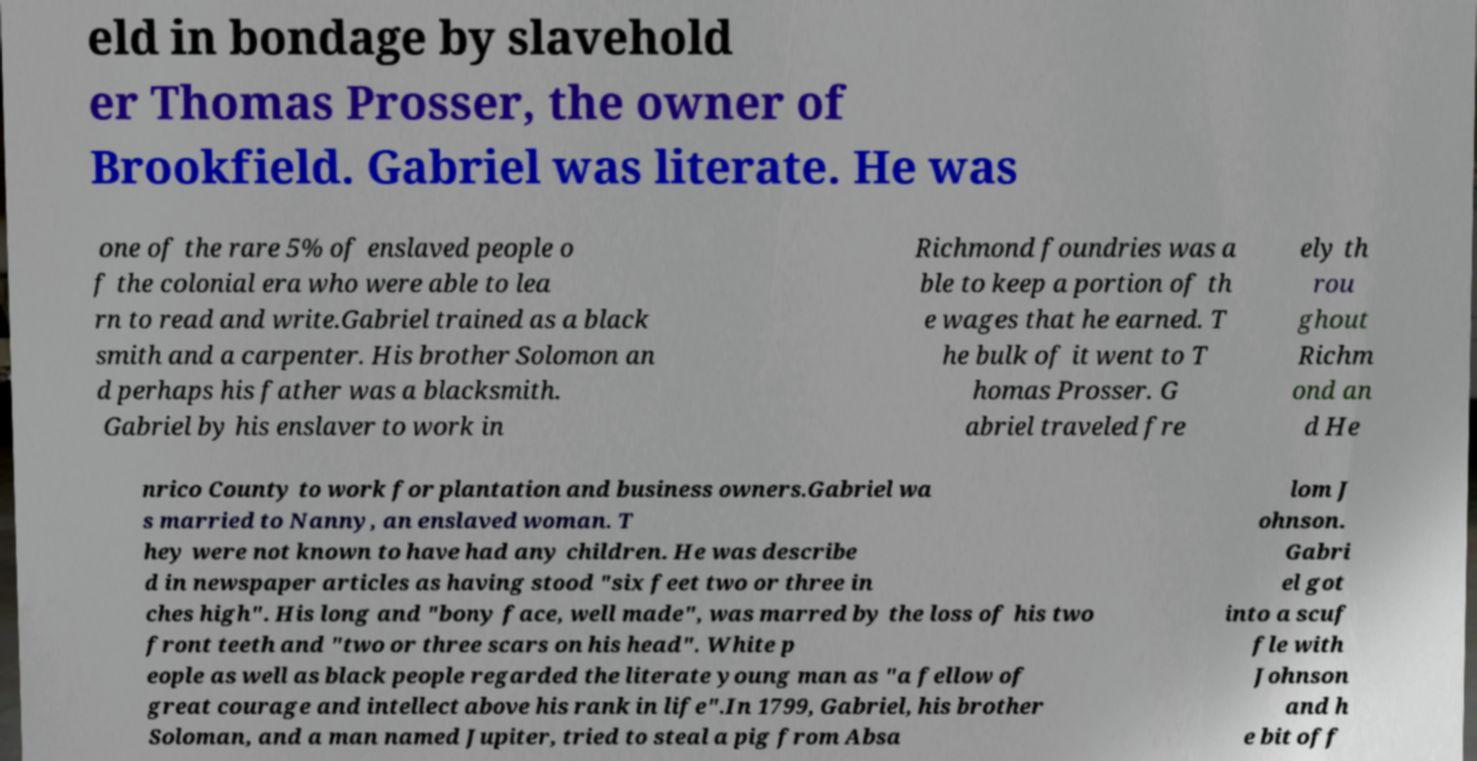What messages or text are displayed in this image? I need them in a readable, typed format. eld in bondage by slavehold er Thomas Prosser, the owner of Brookfield. Gabriel was literate. He was one of the rare 5% of enslaved people o f the colonial era who were able to lea rn to read and write.Gabriel trained as a black smith and a carpenter. His brother Solomon an d perhaps his father was a blacksmith. Gabriel by his enslaver to work in Richmond foundries was a ble to keep a portion of th e wages that he earned. T he bulk of it went to T homas Prosser. G abriel traveled fre ely th rou ghout Richm ond an d He nrico County to work for plantation and business owners.Gabriel wa s married to Nanny, an enslaved woman. T hey were not known to have had any children. He was describe d in newspaper articles as having stood "six feet two or three in ches high". His long and "bony face, well made", was marred by the loss of his two front teeth and "two or three scars on his head". White p eople as well as black people regarded the literate young man as "a fellow of great courage and intellect above his rank in life".In 1799, Gabriel, his brother Soloman, and a man named Jupiter, tried to steal a pig from Absa lom J ohnson. Gabri el got into a scuf fle with Johnson and h e bit off 